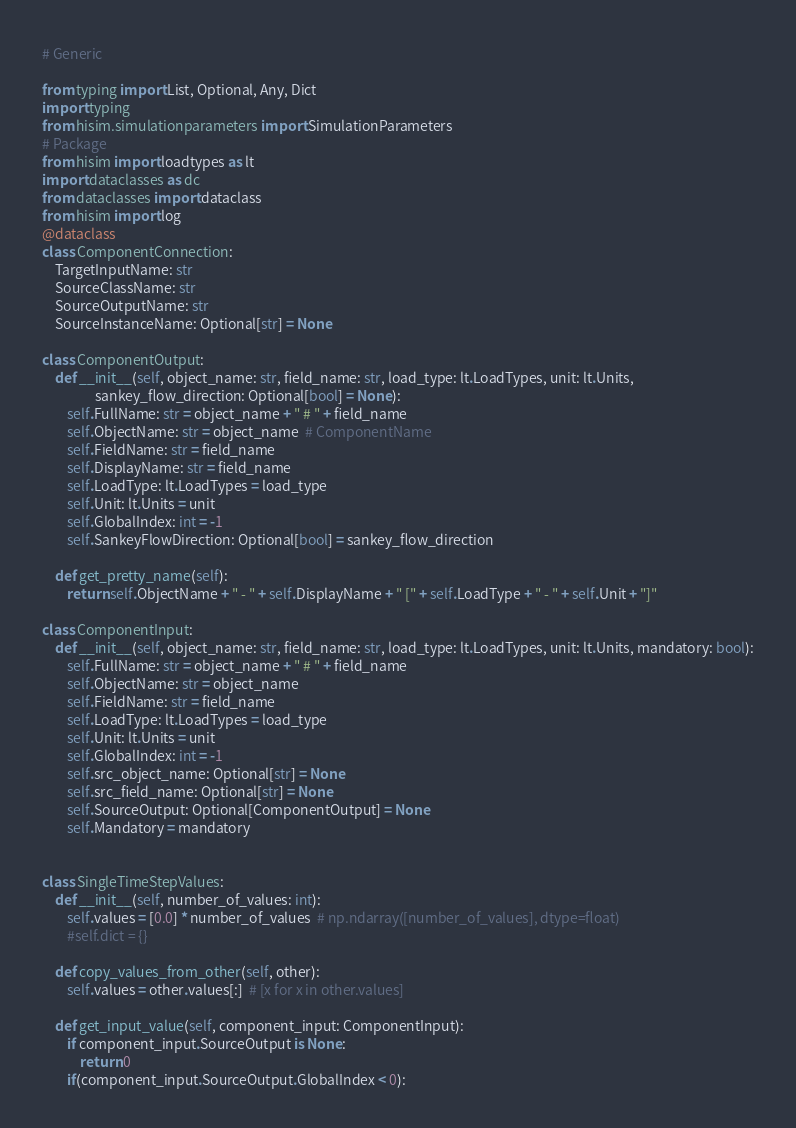<code> <loc_0><loc_0><loc_500><loc_500><_Python_># Generic

from typing import List, Optional, Any, Dict
import typing
from hisim.simulationparameters import SimulationParameters
# Package
from hisim import loadtypes as lt
import dataclasses as dc
from dataclasses import dataclass
from hisim import log
@dataclass
class ComponentConnection:
    TargetInputName: str
    SourceClassName: str
    SourceOutputName: str
    SourceInstanceName: Optional[str] = None

class ComponentOutput:
    def __init__(self, object_name: str, field_name: str, load_type: lt.LoadTypes, unit: lt.Units,
                 sankey_flow_direction: Optional[bool] = None):
        self.FullName: str = object_name + " # " + field_name
        self.ObjectName: str = object_name  # ComponentName
        self.FieldName: str = field_name
        self.DisplayName: str = field_name
        self.LoadType: lt.LoadTypes = load_type
        self.Unit: lt.Units = unit
        self.GlobalIndex: int = -1
        self.SankeyFlowDirection: Optional[bool] = sankey_flow_direction

    def get_pretty_name(self):
        return self.ObjectName + " - " + self.DisplayName + " [" + self.LoadType + " - " + self.Unit + "]"

class ComponentInput:
    def __init__(self, object_name: str, field_name: str, load_type: lt.LoadTypes, unit: lt.Units, mandatory: bool):
        self.FullName: str = object_name + " # " + field_name
        self.ObjectName: str = object_name
        self.FieldName: str = field_name
        self.LoadType: lt.LoadTypes = load_type
        self.Unit: lt.Units = unit
        self.GlobalIndex: int = -1
        self.src_object_name: Optional[str] = None
        self.src_field_name: Optional[str] = None
        self.SourceOutput: Optional[ComponentOutput] = None
        self.Mandatory = mandatory


class SingleTimeStepValues:
    def __init__(self, number_of_values: int):
        self.values = [0.0] * number_of_values  # np.ndarray([number_of_values], dtype=float)
        #self.dict = {}

    def copy_values_from_other(self, other):
        self.values = other.values[:]  # [x for x in other.values]

    def get_input_value(self, component_input: ComponentInput):
        if component_input.SourceOutput is None:
            return 0
        if(component_input.SourceOutput.GlobalIndex < 0):</code> 